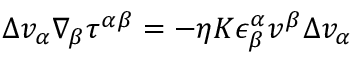Convert formula to latex. <formula><loc_0><loc_0><loc_500><loc_500>\Delta v _ { \alpha } \nabla _ { \beta } \tau ^ { \alpha \beta } = - \eta K \epsilon _ { \beta } ^ { \alpha } v ^ { \beta } \Delta v _ { \alpha }</formula> 